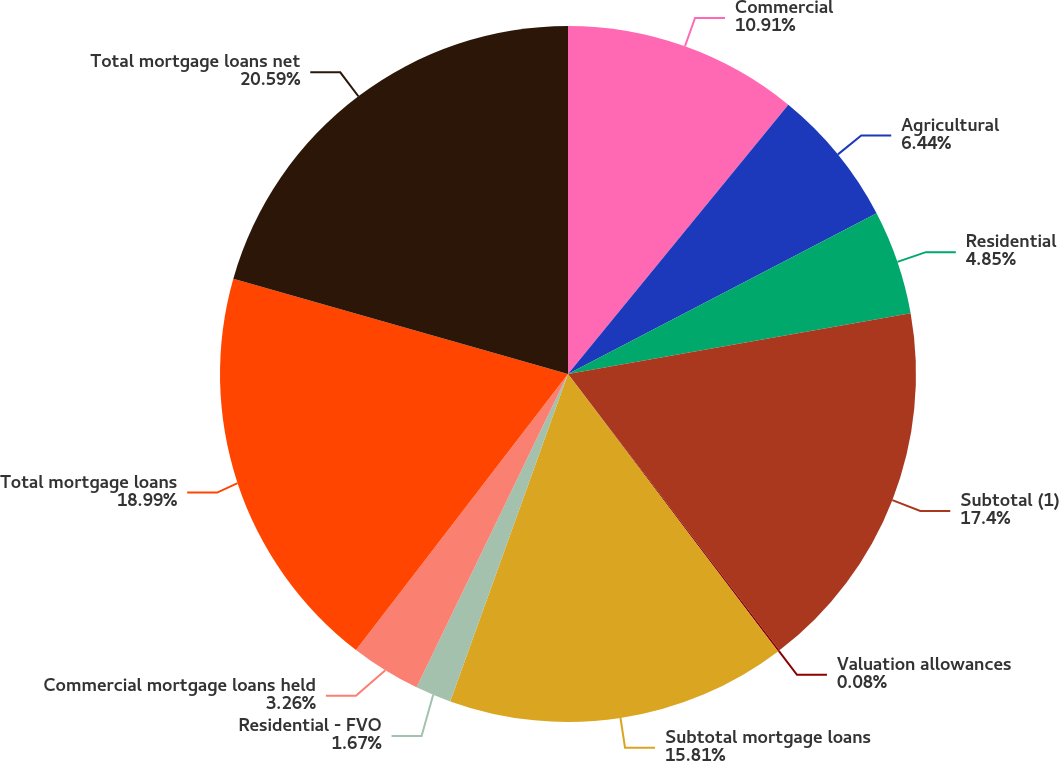<chart> <loc_0><loc_0><loc_500><loc_500><pie_chart><fcel>Commercial<fcel>Agricultural<fcel>Residential<fcel>Subtotal (1)<fcel>Valuation allowances<fcel>Subtotal mortgage loans<fcel>Residential - FVO<fcel>Commercial mortgage loans held<fcel>Total mortgage loans<fcel>Total mortgage loans net<nl><fcel>10.91%<fcel>6.44%<fcel>4.85%<fcel>17.4%<fcel>0.08%<fcel>15.81%<fcel>1.67%<fcel>3.26%<fcel>18.99%<fcel>20.58%<nl></chart> 